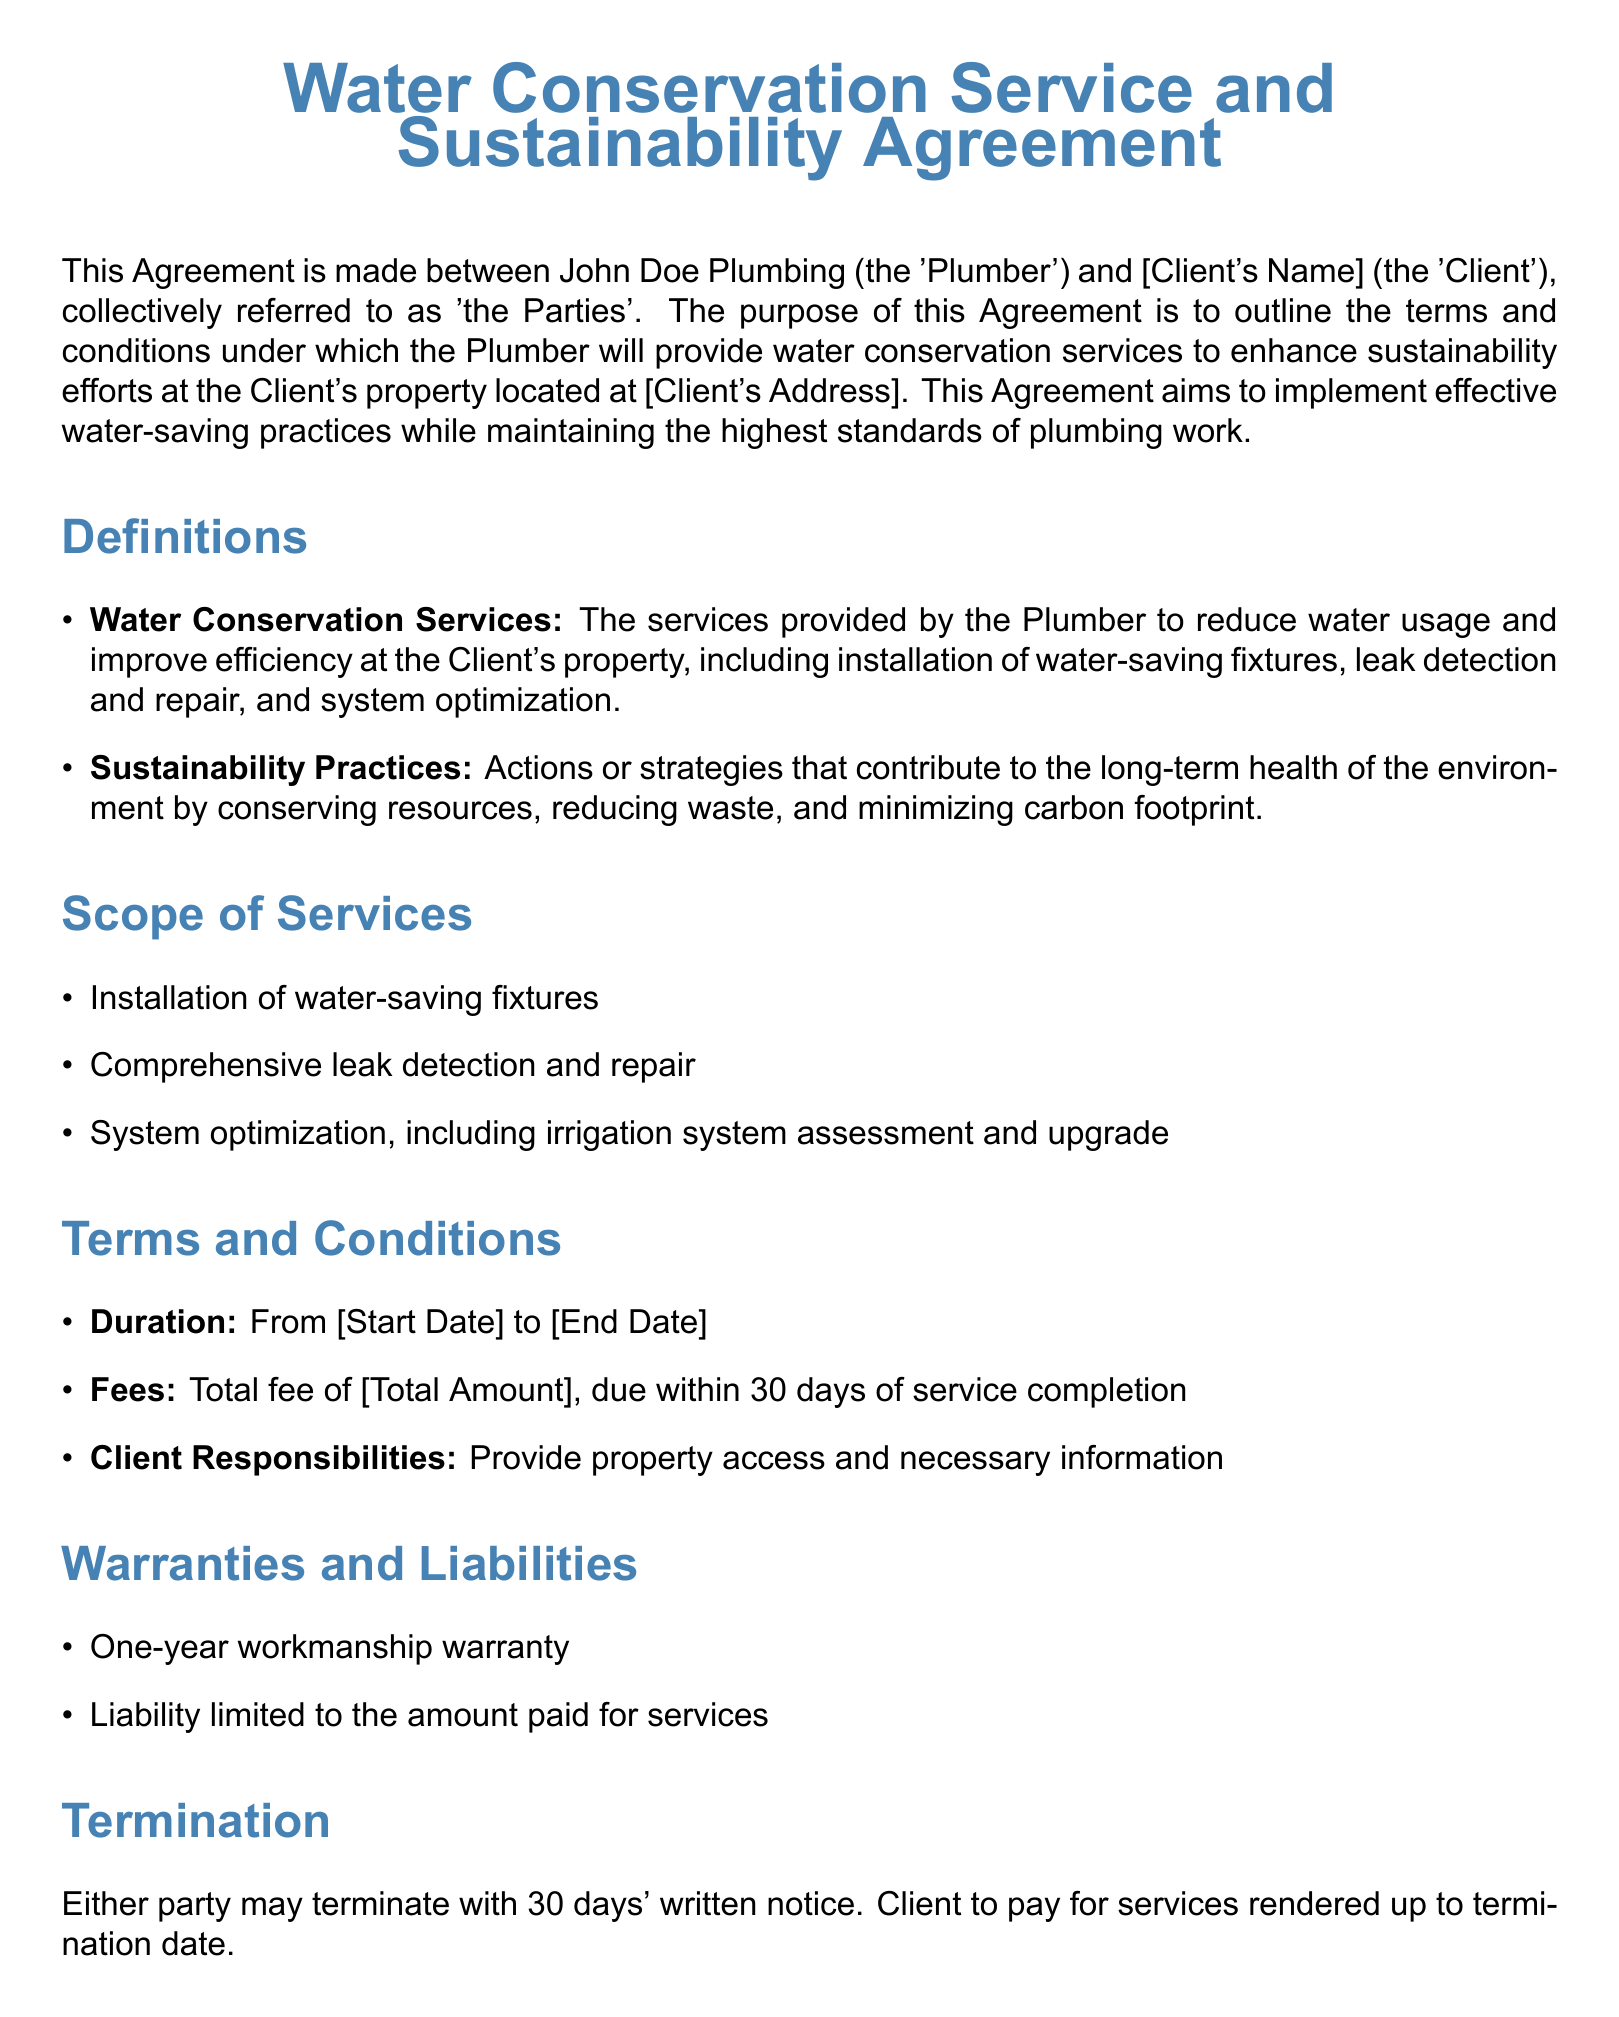What is the title of the document? The title of the document is stated at the beginning as the main heading.
Answer: Water Conservation Service and Sustainability Agreement Who are the parties involved in the Agreement? The document specifies who the parties are in the introductory paragraph.
Answer: John Doe Plumbing and [Client's Name] What services does the Plumber provide? The scope of services section outlines the services offered by the Plumber.
Answer: Installation of water-saving fixtures, leak detection and repair, system optimization What is the duration of the Agreement? The duration is mentioned in the terms and conditions section of the document.
Answer: From [Start Date] to [End Date] What warranty is provided for workmanship? The warranties and liabilities section provides details about the warranty offered.
Answer: One-year workmanship warranty What is the total fee for the services? The fee is stated clearly in the terms and conditions section of the document.
Answer: [Total Amount] What are the Client's responsibilities? The client responsibilities are outlined in the terms and conditions section.
Answer: Provide property access and necessary information Under what conditions can the Agreement be terminated? The termination section specifies the conditions for terminating the Agreement.
Answer: 30 days' written notice Which law governs the Agreement? The miscellaneous section indicates the governing law for the Agreement.
Answer: [State] law 